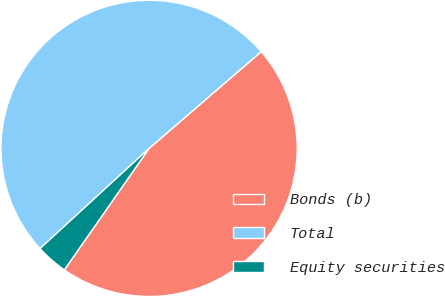Convert chart to OTSL. <chart><loc_0><loc_0><loc_500><loc_500><pie_chart><fcel>Bonds (b)<fcel>Total<fcel>Equity securities<nl><fcel>46.03%<fcel>50.5%<fcel>3.48%<nl></chart> 